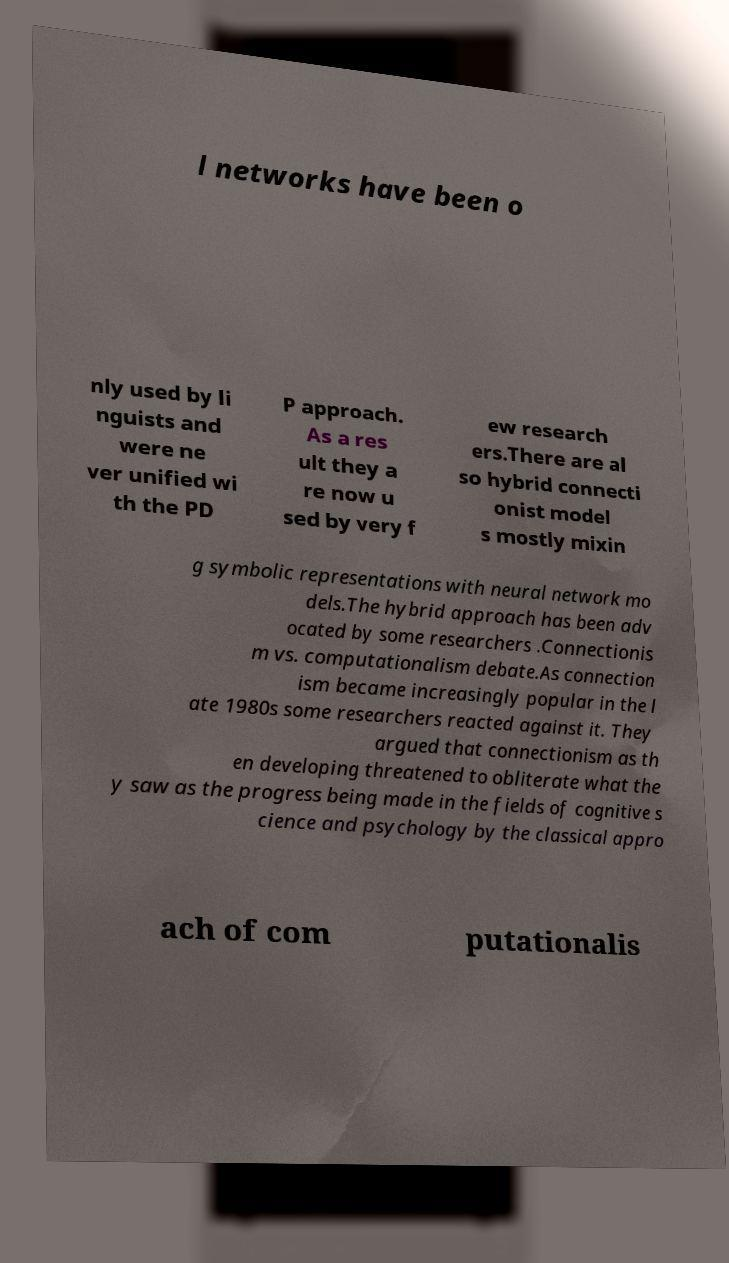What messages or text are displayed in this image? I need them in a readable, typed format. l networks have been o nly used by li nguists and were ne ver unified wi th the PD P approach. As a res ult they a re now u sed by very f ew research ers.There are al so hybrid connecti onist model s mostly mixin g symbolic representations with neural network mo dels.The hybrid approach has been adv ocated by some researchers .Connectionis m vs. computationalism debate.As connection ism became increasingly popular in the l ate 1980s some researchers reacted against it. They argued that connectionism as th en developing threatened to obliterate what the y saw as the progress being made in the fields of cognitive s cience and psychology by the classical appro ach of com putationalis 